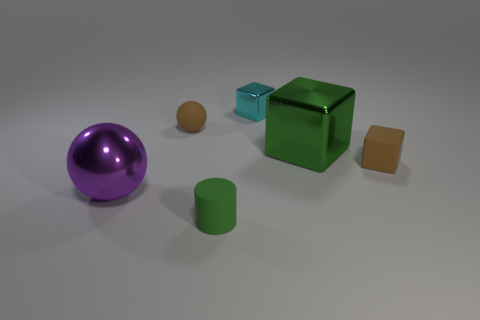What size is the purple thing that is made of the same material as the cyan block?
Offer a terse response. Large. Does the tiny cyan block have the same material as the large block?
Give a very brief answer. Yes. What is the color of the large thing in front of the large metallic thing behind the tiny cube to the right of the tiny shiny thing?
Offer a terse response. Purple. What is the shape of the cyan shiny thing?
Provide a succinct answer. Cube. Is the color of the large block the same as the thing that is in front of the purple object?
Your answer should be very brief. Yes. Are there an equal number of tiny cyan shiny blocks in front of the tiny green matte thing and brown metal things?
Provide a short and direct response. Yes. What number of blue shiny balls are the same size as the matte block?
Your answer should be very brief. 0. There is a small thing that is the same color as the large block; what is its shape?
Give a very brief answer. Cylinder. Are there any tiny cyan shiny things?
Your answer should be compact. Yes. Does the rubber thing that is behind the tiny brown block have the same shape as the big object that is on the left side of the large metal cube?
Your answer should be compact. Yes. 